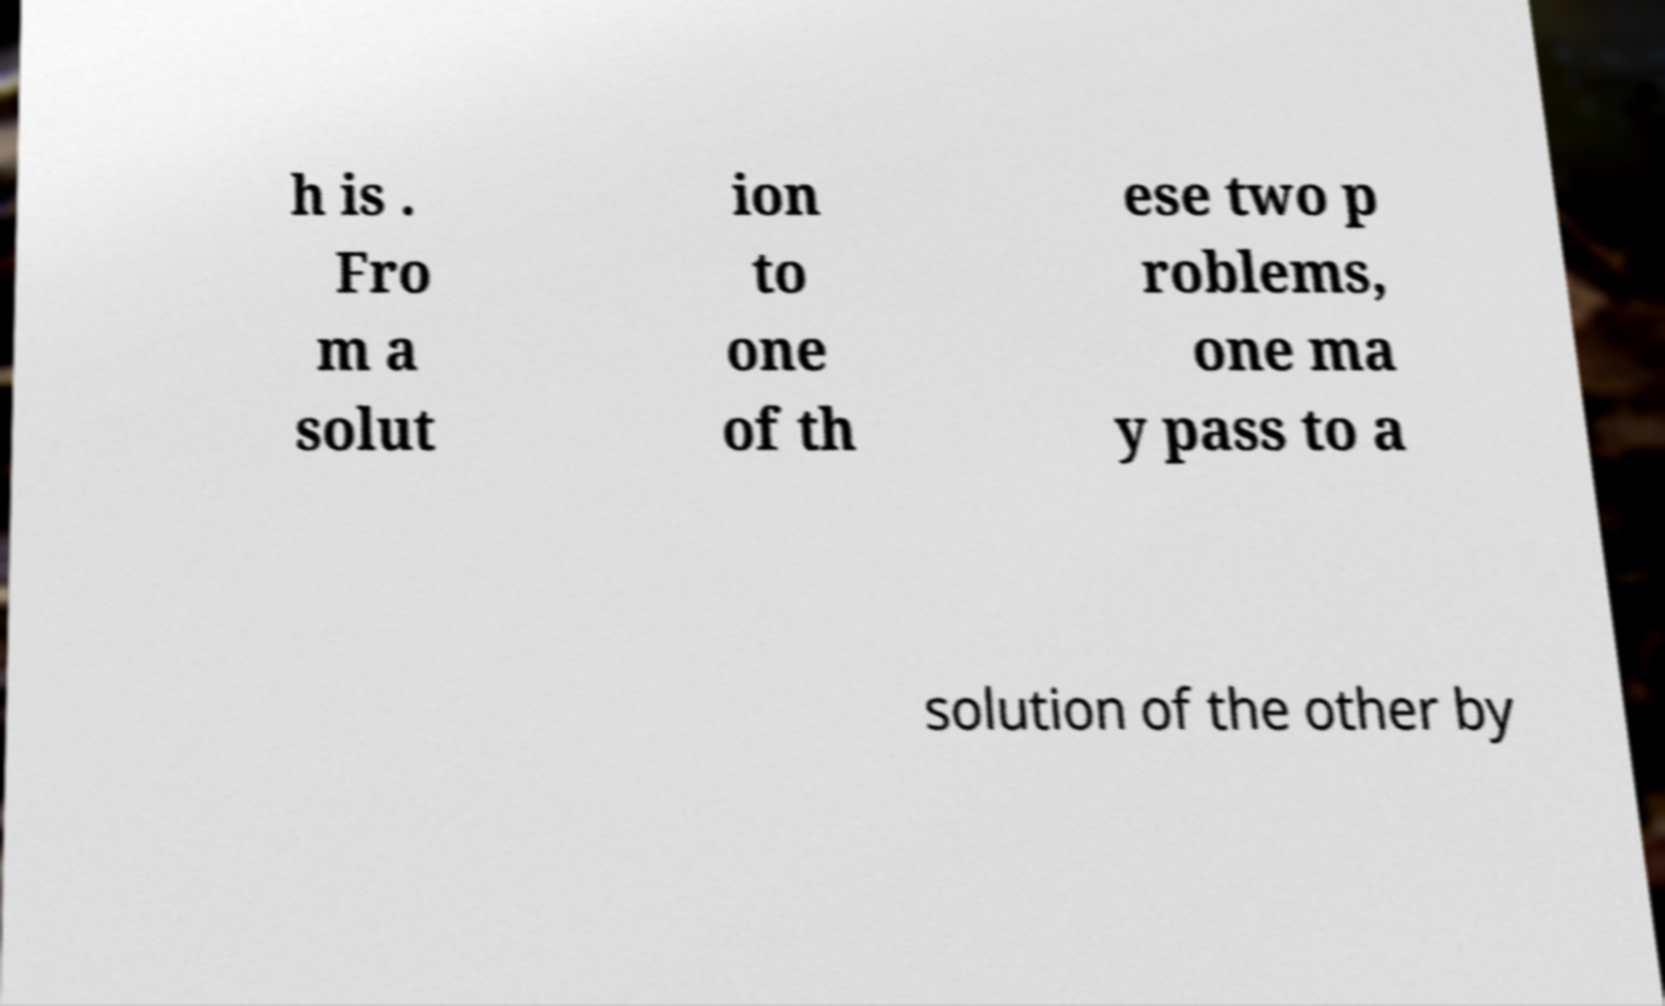Please read and relay the text visible in this image. What does it say? h is . Fro m a solut ion to one of th ese two p roblems, one ma y pass to a solution of the other by 